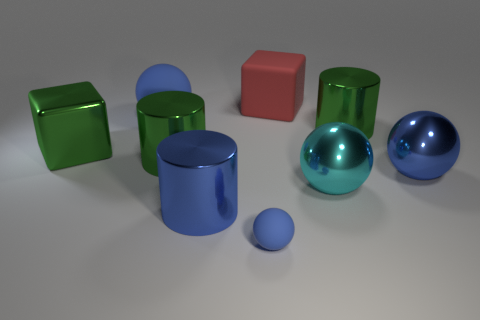How many blue spheres must be subtracted to get 1 blue spheres? 2 Subtract all small blue matte spheres. How many spheres are left? 3 Subtract all blue cylinders. How many cylinders are left? 2 Add 1 big blue cylinders. How many objects exist? 10 Subtract 1 cylinders. How many cylinders are left? 2 Subtract all gray blocks. How many blue cylinders are left? 1 Subtract all small blue things. Subtract all blue metallic things. How many objects are left? 6 Add 2 big green things. How many big green things are left? 5 Add 3 tiny gray matte cylinders. How many tiny gray matte cylinders exist? 3 Subtract 0 purple balls. How many objects are left? 9 